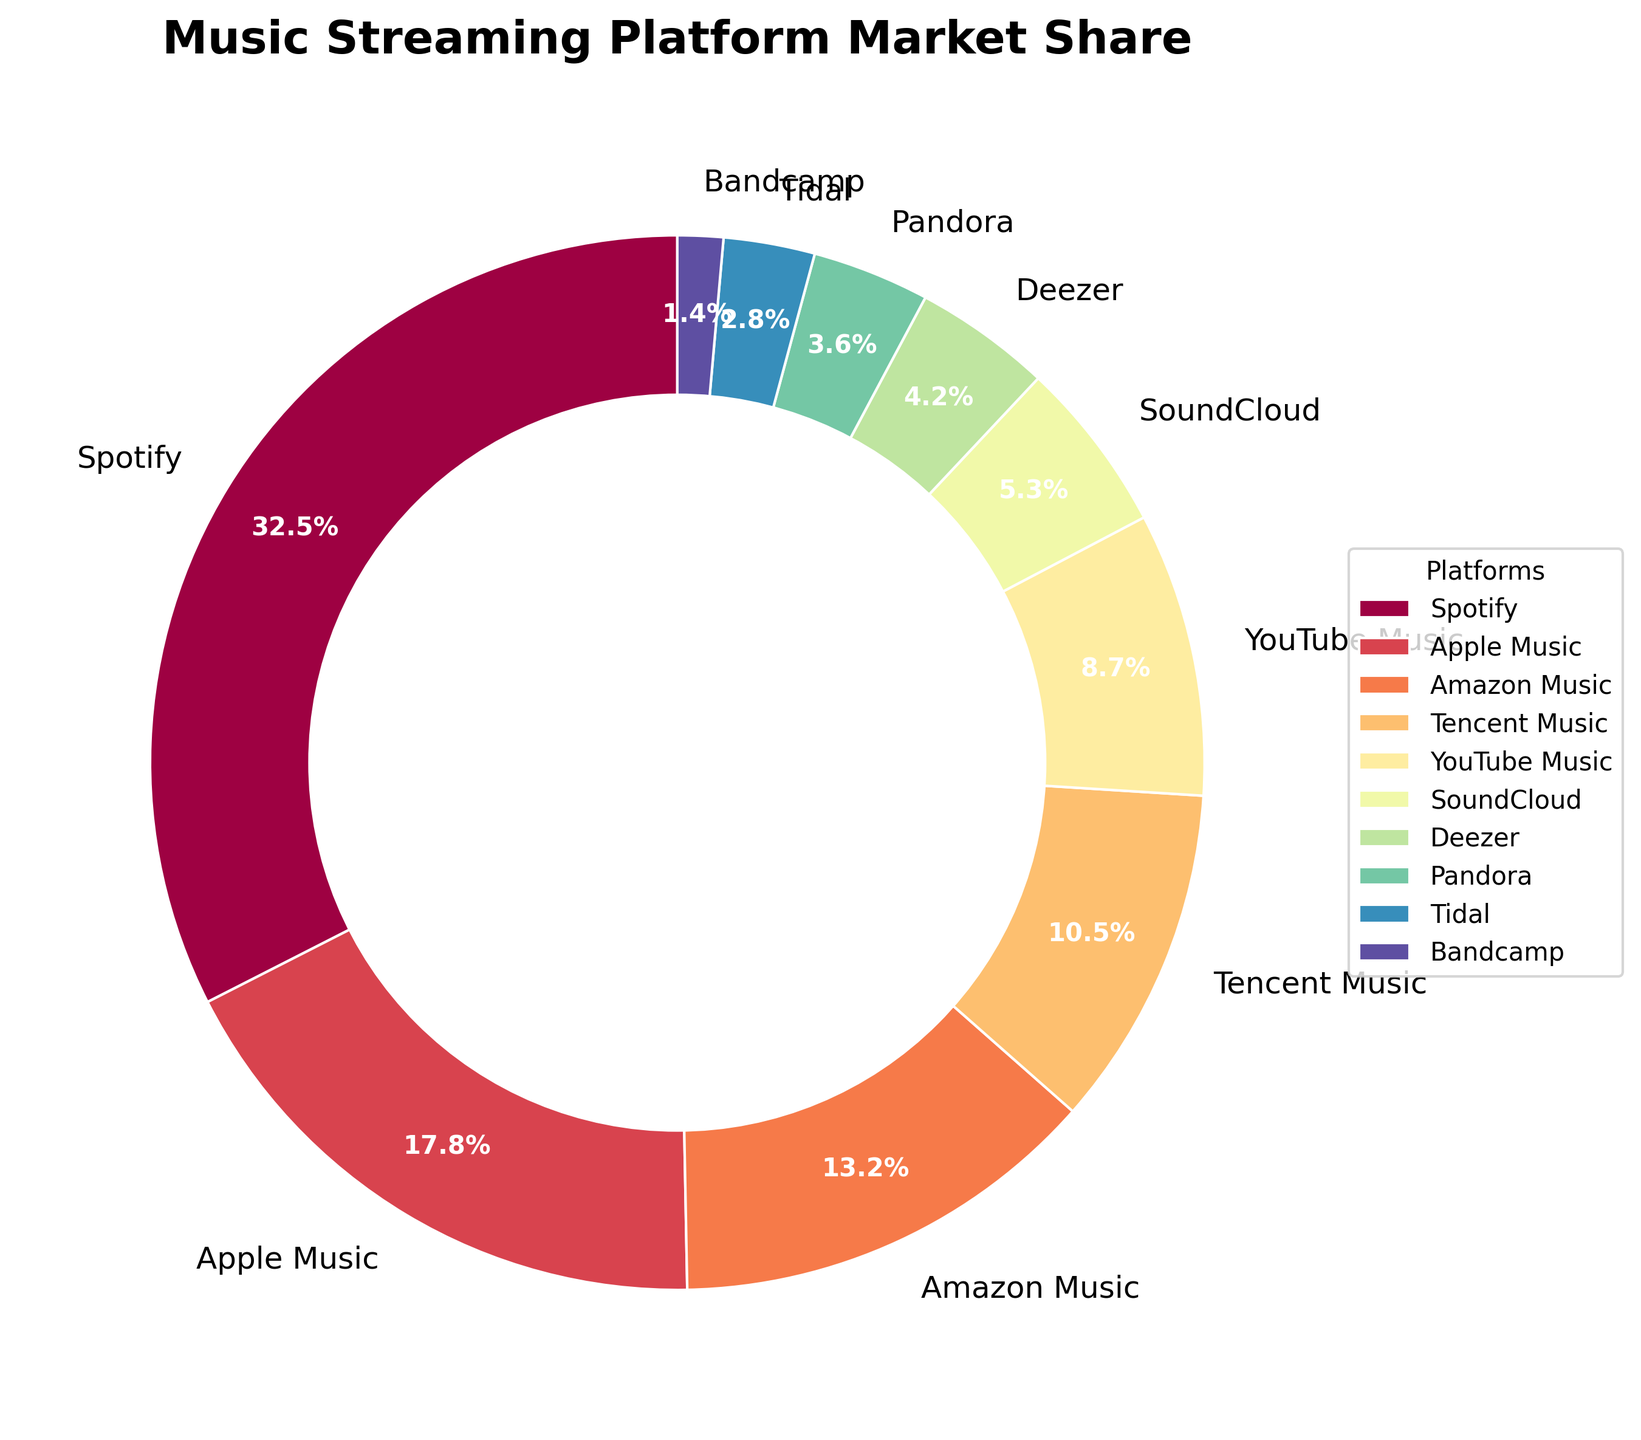What's the largest market share among the platforms? The figure shows the market share distribution of various platforms. Spotify has the largest slice of the pie chart.
Answer: Spotify Which platforms have a market share less than 5%? We just need to look for platforms with slices that have smaller percentages. The platforms are SoundCloud, Deezer, Pandora, Tidal, and Bandcamp.
Answer: SoundCloud, Deezer, Pandora, Tidal, Bandcamp How much larger is Spotify's market share compared to Apple Music? Spotify's market share is 32.5% and Apple Music's is 17.8%. Subtract Apple Music's share from Spotify's: 32.5% - 17.8% = 14.7%.
Answer: 14.7% What is the total market share of the top three platforms? The top three platforms are Spotify (32.5%), Apple Music (17.8%), and Amazon Music (13.2%). Adding these gives: 32.5% + 17.8% + 13.2% = 63.5%.
Answer: 63.5% What percentage of the market do YouTube Music and Tencent Music together hold? The market share of YouTube Music is 8.7% and Tencent Music is 10.5%. Adding these gives: 8.7% + 10.5% = 19.2%.
Answer: 19.2% How many platforms have a market share equal to or greater than 10%? By scanning the chart, we see that Spotify, Apple Music, Amazon Music, and Tencent Music each have more than 10% market share. That's four platforms.
Answer: Four Which platform has the smallest market share? By looking at the smallest slice in the pie chart, it is clear that Bandcamp has the smallest share at 1.4%.
Answer: Bandcamp What is the average market share of Deezer, Pandora, and Tidal? The market shares are Deezer (4.2%), Pandora (3.6%), and Tidal (2.8%). Summing these gives 4.2% + 3.6% + 2.8% = 10.6%. Dividing by 3 platforms gives: 10.6% / 3 = 3.53%.
Answer: 3.53% Among the listed platforms, which one is closest to having a market share of 5%? By comparing the shares, SoundCloud has a market share of 5.3%, which is closest to 5%.
Answer: SoundCloud 